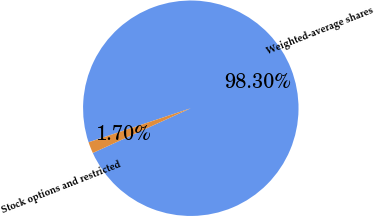Convert chart. <chart><loc_0><loc_0><loc_500><loc_500><pie_chart><fcel>Weighted-average shares<fcel>Stock options and restricted<nl><fcel>98.3%<fcel>1.7%<nl></chart> 